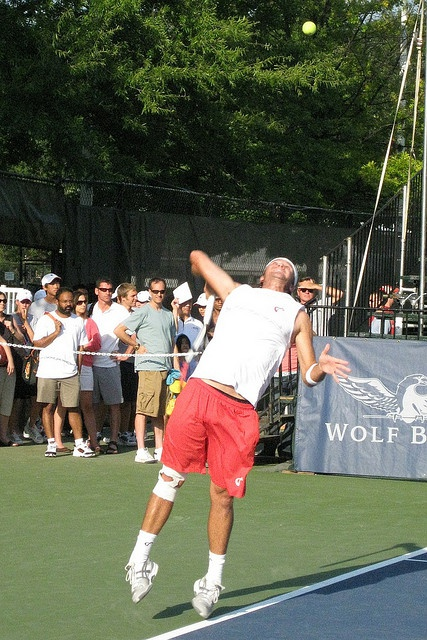Describe the objects in this image and their specific colors. I can see people in gray, white, salmon, and tan tones, people in gray, lightgray, tan, and black tones, people in gray, white, darkgray, and tan tones, people in gray, white, black, and darkgray tones, and people in gray, white, black, and darkgray tones in this image. 